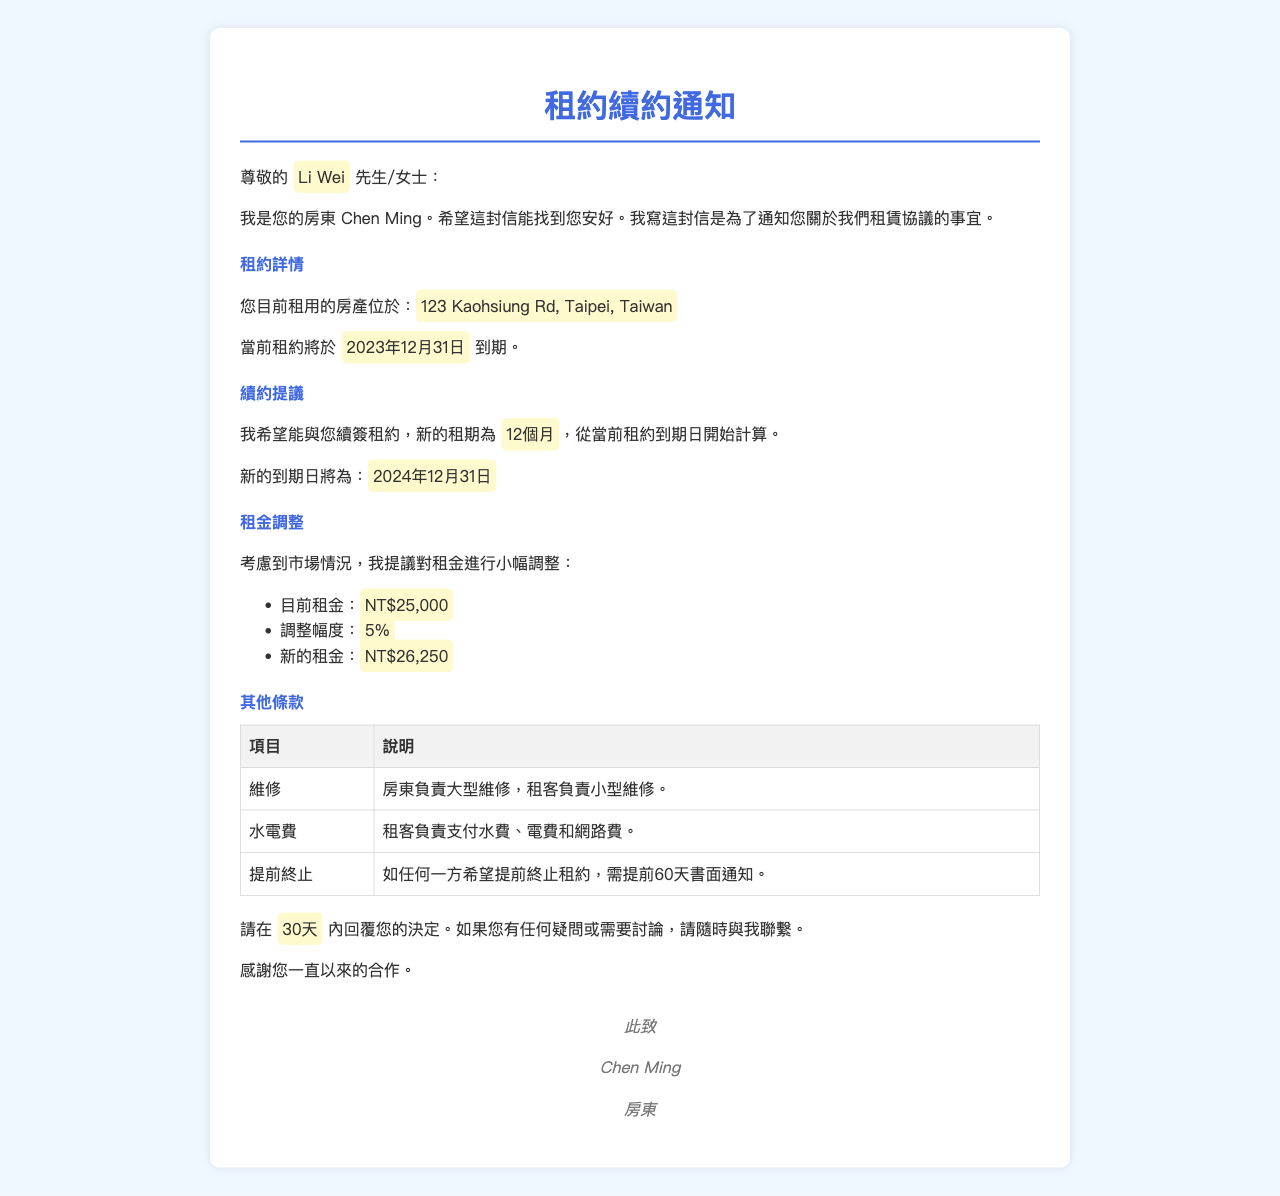什麼是新的租金？ 新的租金是根據租金調整後的金額，為NT$26,250。
Answer: NT$26,250 新的租約到期日是什麼？ 新的到期日是根據續約提議計算的，為2024年12月31日。
Answer: 2024年12月31日 租客負責支付哪些費用？ 租客需要支付水費、電費和網路費。
Answer: 水費、電費和網路費 如果想提前終止租約，需提前多久通知？ 提前終止租約需要提前60天書面通知。
Answer: 60天 目前的租金是多少？ 目前的租金是租客每月需要支付的原始金額，為NT$25,000。
Answer: NT$25,000 續約的租期是多久？ 續約的租期是根據信中提到的新租約期限，為12個月。
Answer: 12個月 誰負責大型維修？ 根據條款，大型維修由房東負責。
Answer: 房東 何時需要回覆決定？ 根據信件內容，需在30天內返回決定。
Answer: 30天 